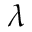<formula> <loc_0><loc_0><loc_500><loc_500>\lambda</formula> 